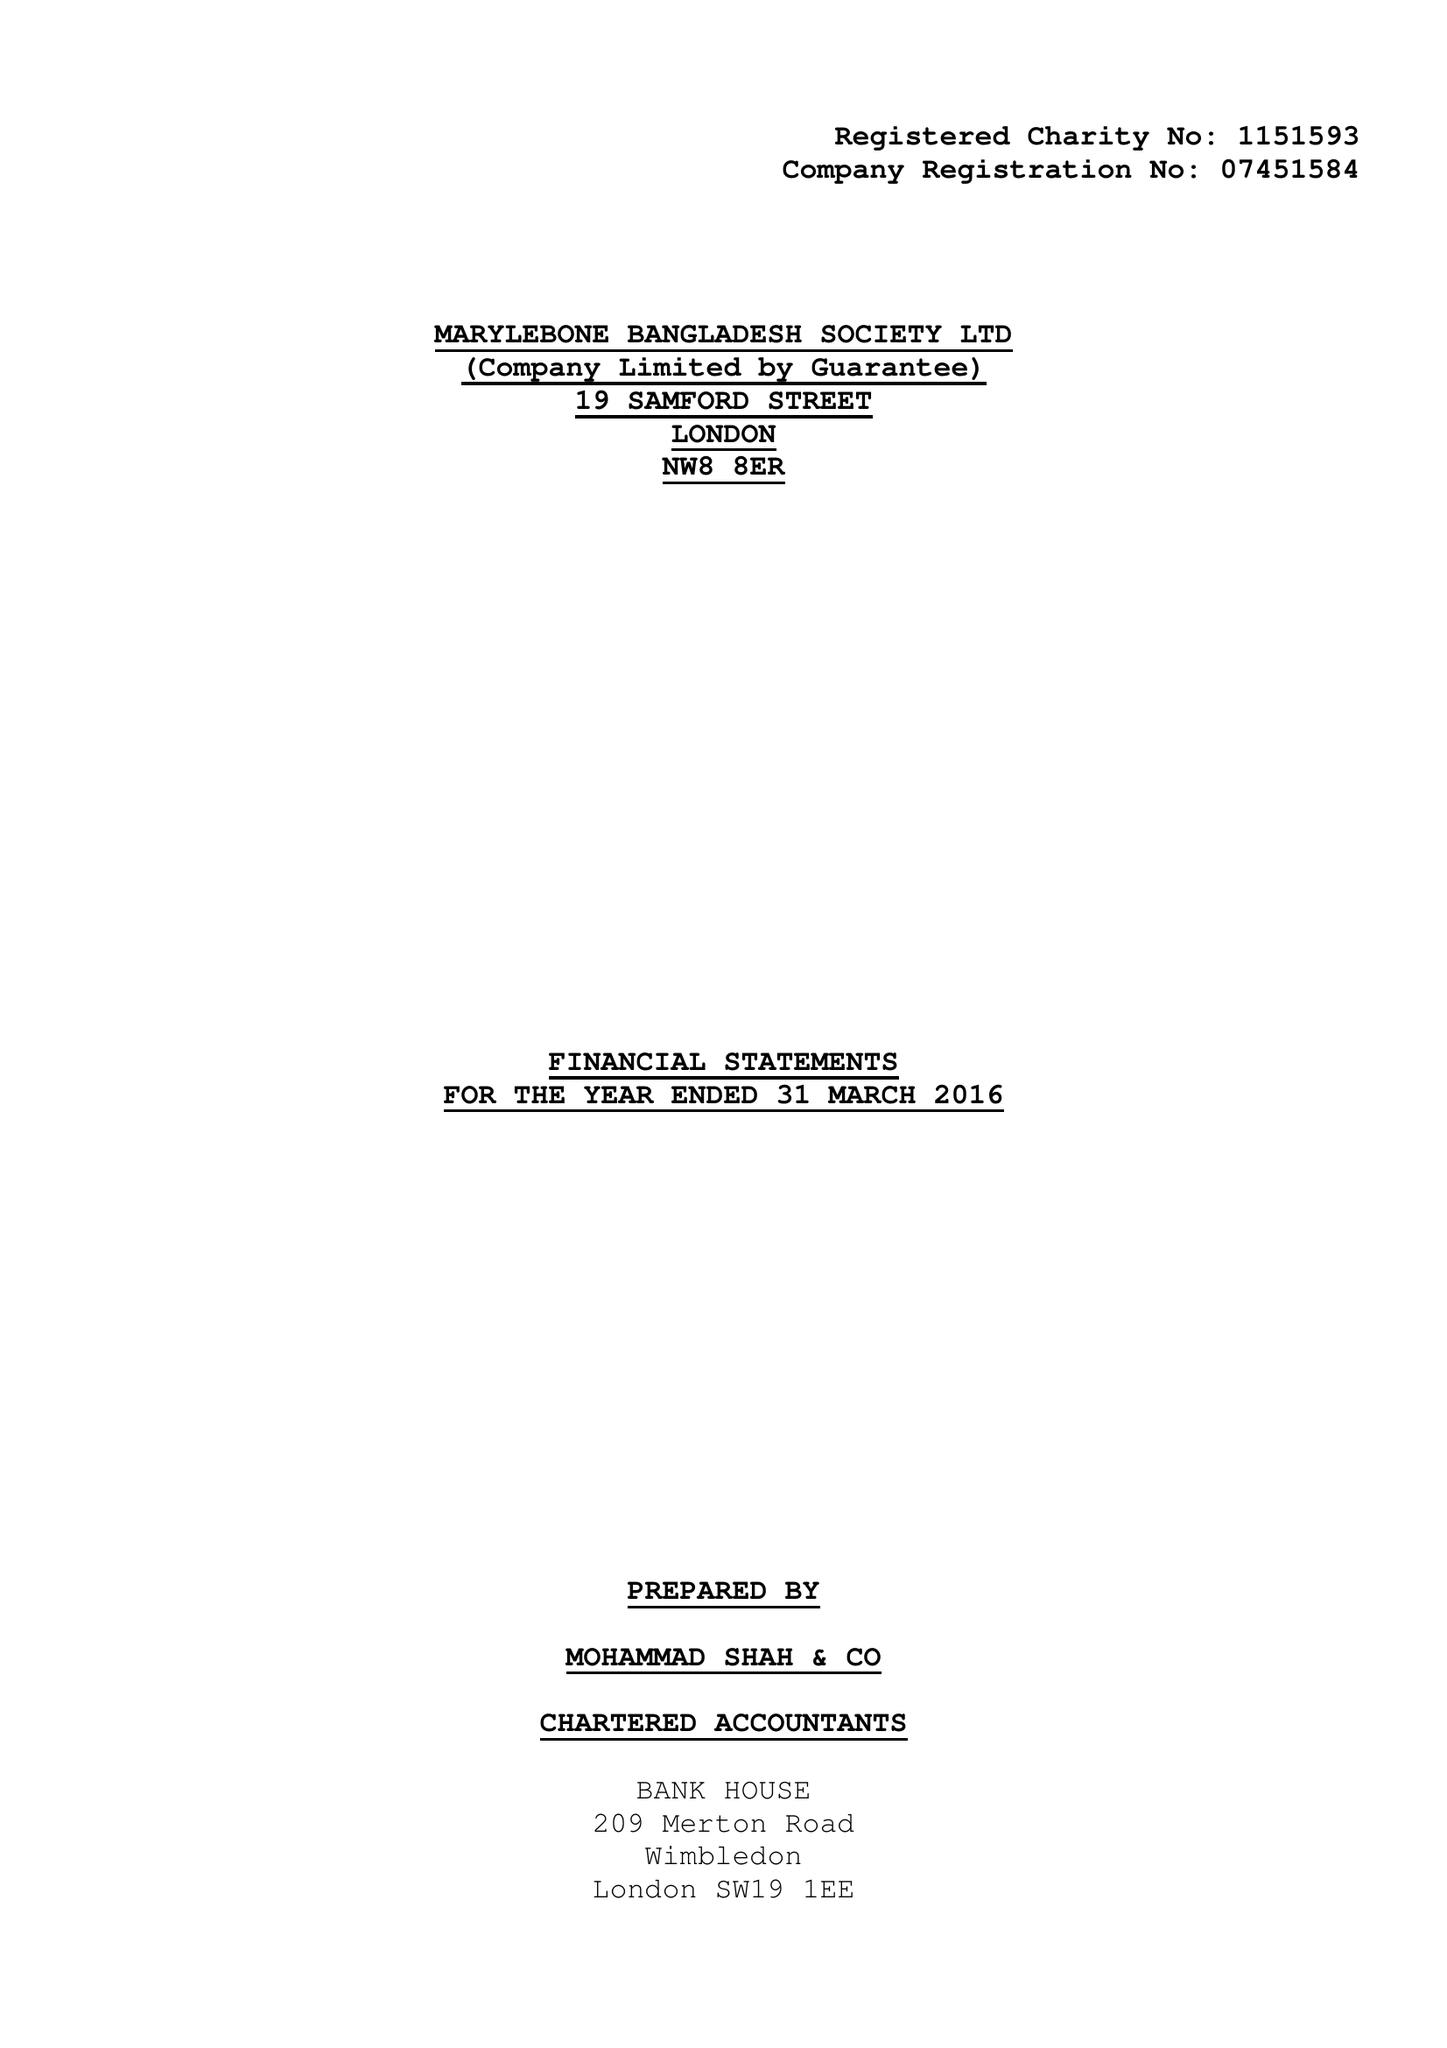What is the value for the charity_name?
Answer the question using a single word or phrase. Marylebone Bangladesh Society Ltd. 